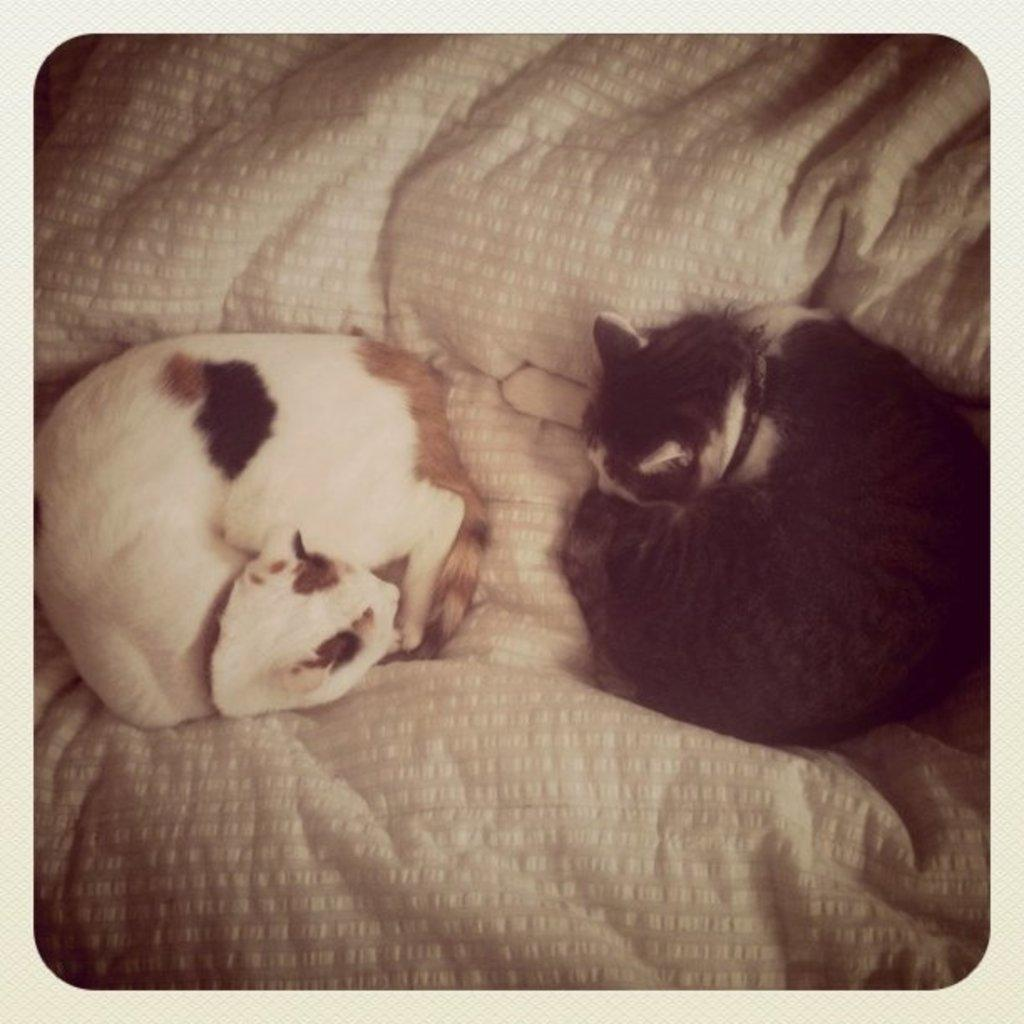How many cats are in the image? There are two cats in the image. What are the cats doing in the image? The cats are sleeping opposite to each other. What are the colors of the cats? One cat is black, and the other cat is white. Where are the cats located in the image? The cats are on a bed sheet. What type of rice is being cooked in the image? There is no rice present in the image; it features two cats sleeping on a bed sheet. Is the watch visible in the image? There is no watch present in the image. 